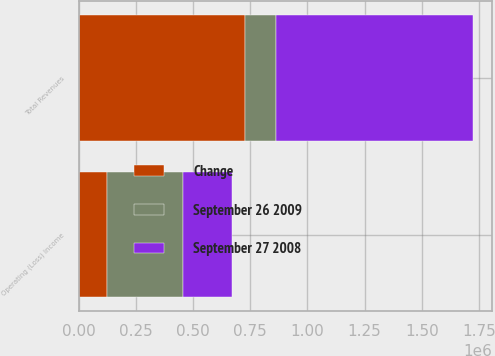Convert chart to OTSL. <chart><loc_0><loc_0><loc_500><loc_500><stacked_bar_chart><ecel><fcel>Total Revenues<fcel>Operating (Loss) Income<nl><fcel>Change<fcel>728884<fcel>122559<nl><fcel>September 27 2008<fcel>860848<fcel>211704<nl><fcel>September 26 2009<fcel>131964<fcel>334263<nl></chart> 